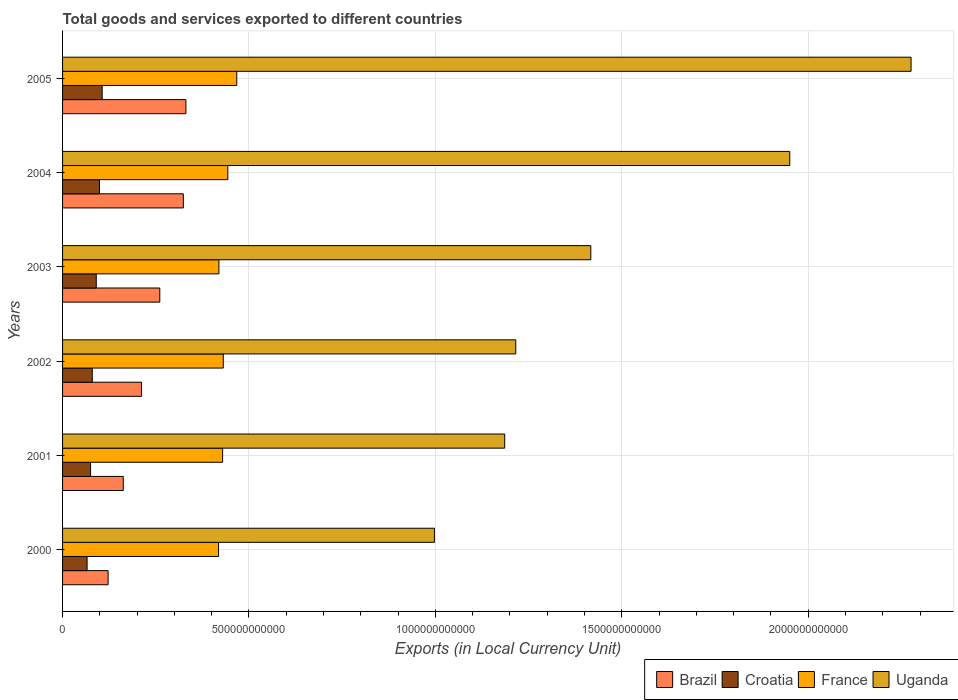How many different coloured bars are there?
Make the answer very short. 4. Are the number of bars per tick equal to the number of legend labels?
Keep it short and to the point. Yes. Are the number of bars on each tick of the Y-axis equal?
Keep it short and to the point. Yes. How many bars are there on the 3rd tick from the bottom?
Keep it short and to the point. 4. In how many cases, is the number of bars for a given year not equal to the number of legend labels?
Provide a short and direct response. 0. What is the Amount of goods and services exports in France in 2000?
Offer a terse response. 4.18e+11. Across all years, what is the maximum Amount of goods and services exports in Uganda?
Ensure brevity in your answer.  2.28e+12. Across all years, what is the minimum Amount of goods and services exports in Croatia?
Give a very brief answer. 6.58e+1. What is the total Amount of goods and services exports in France in the graph?
Provide a short and direct response. 2.61e+12. What is the difference between the Amount of goods and services exports in Croatia in 2003 and that in 2005?
Your answer should be compact. -1.58e+1. What is the difference between the Amount of goods and services exports in France in 2004 and the Amount of goods and services exports in Brazil in 2002?
Provide a succinct answer. 2.31e+11. What is the average Amount of goods and services exports in Uganda per year?
Ensure brevity in your answer.  1.51e+12. In the year 2002, what is the difference between the Amount of goods and services exports in France and Amount of goods and services exports in Uganda?
Make the answer very short. -7.85e+11. In how many years, is the Amount of goods and services exports in France greater than 900000000000 LCU?
Provide a short and direct response. 0. What is the ratio of the Amount of goods and services exports in Croatia in 2002 to that in 2003?
Provide a short and direct response. 0.88. Is the difference between the Amount of goods and services exports in France in 2001 and 2003 greater than the difference between the Amount of goods and services exports in Uganda in 2001 and 2003?
Your response must be concise. Yes. What is the difference between the highest and the second highest Amount of goods and services exports in Uganda?
Your answer should be compact. 3.25e+11. What is the difference between the highest and the lowest Amount of goods and services exports in Brazil?
Your answer should be compact. 2.09e+11. Is the sum of the Amount of goods and services exports in Croatia in 2002 and 2003 greater than the maximum Amount of goods and services exports in Uganda across all years?
Offer a very short reply. No. What does the 4th bar from the bottom in 2002 represents?
Provide a succinct answer. Uganda. Is it the case that in every year, the sum of the Amount of goods and services exports in Croatia and Amount of goods and services exports in France is greater than the Amount of goods and services exports in Brazil?
Provide a succinct answer. Yes. How many bars are there?
Make the answer very short. 24. What is the difference between two consecutive major ticks on the X-axis?
Provide a succinct answer. 5.00e+11. How are the legend labels stacked?
Offer a very short reply. Horizontal. What is the title of the graph?
Make the answer very short. Total goods and services exported to different countries. Does "Malawi" appear as one of the legend labels in the graph?
Your response must be concise. No. What is the label or title of the X-axis?
Make the answer very short. Exports (in Local Currency Unit). What is the Exports (in Local Currency Unit) in Brazil in 2000?
Provide a succinct answer. 1.22e+11. What is the Exports (in Local Currency Unit) in Croatia in 2000?
Give a very brief answer. 6.58e+1. What is the Exports (in Local Currency Unit) of France in 2000?
Offer a very short reply. 4.18e+11. What is the Exports (in Local Currency Unit) in Uganda in 2000?
Your response must be concise. 9.97e+11. What is the Exports (in Local Currency Unit) of Brazil in 2001?
Offer a very short reply. 1.63e+11. What is the Exports (in Local Currency Unit) in Croatia in 2001?
Ensure brevity in your answer.  7.51e+1. What is the Exports (in Local Currency Unit) of France in 2001?
Make the answer very short. 4.29e+11. What is the Exports (in Local Currency Unit) in Uganda in 2001?
Give a very brief answer. 1.19e+12. What is the Exports (in Local Currency Unit) in Brazil in 2002?
Make the answer very short. 2.12e+11. What is the Exports (in Local Currency Unit) of Croatia in 2002?
Make the answer very short. 7.97e+1. What is the Exports (in Local Currency Unit) in France in 2002?
Your response must be concise. 4.31e+11. What is the Exports (in Local Currency Unit) in Uganda in 2002?
Ensure brevity in your answer.  1.22e+12. What is the Exports (in Local Currency Unit) of Brazil in 2003?
Ensure brevity in your answer.  2.61e+11. What is the Exports (in Local Currency Unit) in Croatia in 2003?
Give a very brief answer. 9.04e+1. What is the Exports (in Local Currency Unit) in France in 2003?
Offer a very short reply. 4.19e+11. What is the Exports (in Local Currency Unit) of Uganda in 2003?
Provide a short and direct response. 1.42e+12. What is the Exports (in Local Currency Unit) in Brazil in 2004?
Offer a very short reply. 3.24e+11. What is the Exports (in Local Currency Unit) in Croatia in 2004?
Ensure brevity in your answer.  9.90e+1. What is the Exports (in Local Currency Unit) in France in 2004?
Provide a short and direct response. 4.43e+11. What is the Exports (in Local Currency Unit) in Uganda in 2004?
Your answer should be compact. 1.95e+12. What is the Exports (in Local Currency Unit) in Brazil in 2005?
Offer a very short reply. 3.31e+11. What is the Exports (in Local Currency Unit) in Croatia in 2005?
Provide a succinct answer. 1.06e+11. What is the Exports (in Local Currency Unit) in France in 2005?
Make the answer very short. 4.67e+11. What is the Exports (in Local Currency Unit) of Uganda in 2005?
Provide a succinct answer. 2.28e+12. Across all years, what is the maximum Exports (in Local Currency Unit) in Brazil?
Offer a very short reply. 3.31e+11. Across all years, what is the maximum Exports (in Local Currency Unit) of Croatia?
Your answer should be compact. 1.06e+11. Across all years, what is the maximum Exports (in Local Currency Unit) in France?
Your response must be concise. 4.67e+11. Across all years, what is the maximum Exports (in Local Currency Unit) in Uganda?
Provide a succinct answer. 2.28e+12. Across all years, what is the minimum Exports (in Local Currency Unit) of Brazil?
Offer a very short reply. 1.22e+11. Across all years, what is the minimum Exports (in Local Currency Unit) of Croatia?
Your response must be concise. 6.58e+1. Across all years, what is the minimum Exports (in Local Currency Unit) of France?
Provide a succinct answer. 4.18e+11. Across all years, what is the minimum Exports (in Local Currency Unit) of Uganda?
Your answer should be compact. 9.97e+11. What is the total Exports (in Local Currency Unit) in Brazil in the graph?
Make the answer very short. 1.41e+12. What is the total Exports (in Local Currency Unit) in Croatia in the graph?
Give a very brief answer. 5.16e+11. What is the total Exports (in Local Currency Unit) in France in the graph?
Your answer should be very brief. 2.61e+12. What is the total Exports (in Local Currency Unit) of Uganda in the graph?
Provide a short and direct response. 9.04e+12. What is the difference between the Exports (in Local Currency Unit) in Brazil in 2000 and that in 2001?
Make the answer very short. -4.06e+1. What is the difference between the Exports (in Local Currency Unit) in Croatia in 2000 and that in 2001?
Your answer should be very brief. -9.31e+09. What is the difference between the Exports (in Local Currency Unit) of France in 2000 and that in 2001?
Give a very brief answer. -1.09e+1. What is the difference between the Exports (in Local Currency Unit) in Uganda in 2000 and that in 2001?
Your answer should be compact. -1.89e+11. What is the difference between the Exports (in Local Currency Unit) of Brazil in 2000 and that in 2002?
Keep it short and to the point. -8.97e+1. What is the difference between the Exports (in Local Currency Unit) in Croatia in 2000 and that in 2002?
Keep it short and to the point. -1.39e+1. What is the difference between the Exports (in Local Currency Unit) in France in 2000 and that in 2002?
Your answer should be very brief. -1.26e+1. What is the difference between the Exports (in Local Currency Unit) in Uganda in 2000 and that in 2002?
Your answer should be very brief. -2.18e+11. What is the difference between the Exports (in Local Currency Unit) of Brazil in 2000 and that in 2003?
Offer a terse response. -1.39e+11. What is the difference between the Exports (in Local Currency Unit) of Croatia in 2000 and that in 2003?
Provide a succinct answer. -2.46e+1. What is the difference between the Exports (in Local Currency Unit) in France in 2000 and that in 2003?
Offer a very short reply. -9.01e+08. What is the difference between the Exports (in Local Currency Unit) in Uganda in 2000 and that in 2003?
Provide a short and direct response. -4.19e+11. What is the difference between the Exports (in Local Currency Unit) in Brazil in 2000 and that in 2004?
Provide a succinct answer. -2.02e+11. What is the difference between the Exports (in Local Currency Unit) of Croatia in 2000 and that in 2004?
Offer a very short reply. -3.32e+1. What is the difference between the Exports (in Local Currency Unit) in France in 2000 and that in 2004?
Offer a very short reply. -2.48e+1. What is the difference between the Exports (in Local Currency Unit) of Uganda in 2000 and that in 2004?
Give a very brief answer. -9.53e+11. What is the difference between the Exports (in Local Currency Unit) of Brazil in 2000 and that in 2005?
Ensure brevity in your answer.  -2.09e+11. What is the difference between the Exports (in Local Currency Unit) of Croatia in 2000 and that in 2005?
Keep it short and to the point. -4.04e+1. What is the difference between the Exports (in Local Currency Unit) in France in 2000 and that in 2005?
Provide a short and direct response. -4.88e+1. What is the difference between the Exports (in Local Currency Unit) in Uganda in 2000 and that in 2005?
Keep it short and to the point. -1.28e+12. What is the difference between the Exports (in Local Currency Unit) of Brazil in 2001 and that in 2002?
Provide a succinct answer. -4.91e+1. What is the difference between the Exports (in Local Currency Unit) in Croatia in 2001 and that in 2002?
Your answer should be very brief. -4.60e+09. What is the difference between the Exports (in Local Currency Unit) of France in 2001 and that in 2002?
Provide a short and direct response. -1.77e+09. What is the difference between the Exports (in Local Currency Unit) of Uganda in 2001 and that in 2002?
Keep it short and to the point. -2.97e+1. What is the difference between the Exports (in Local Currency Unit) in Brazil in 2001 and that in 2003?
Provide a succinct answer. -9.80e+1. What is the difference between the Exports (in Local Currency Unit) of Croatia in 2001 and that in 2003?
Offer a terse response. -1.53e+1. What is the difference between the Exports (in Local Currency Unit) of France in 2001 and that in 2003?
Make the answer very short. 9.96e+09. What is the difference between the Exports (in Local Currency Unit) of Uganda in 2001 and that in 2003?
Give a very brief answer. -2.31e+11. What is the difference between the Exports (in Local Currency Unit) in Brazil in 2001 and that in 2004?
Make the answer very short. -1.61e+11. What is the difference between the Exports (in Local Currency Unit) in Croatia in 2001 and that in 2004?
Your response must be concise. -2.39e+1. What is the difference between the Exports (in Local Currency Unit) of France in 2001 and that in 2004?
Make the answer very short. -1.39e+1. What is the difference between the Exports (in Local Currency Unit) of Uganda in 2001 and that in 2004?
Your answer should be very brief. -7.65e+11. What is the difference between the Exports (in Local Currency Unit) of Brazil in 2001 and that in 2005?
Your answer should be very brief. -1.68e+11. What is the difference between the Exports (in Local Currency Unit) in Croatia in 2001 and that in 2005?
Make the answer very short. -3.11e+1. What is the difference between the Exports (in Local Currency Unit) in France in 2001 and that in 2005?
Ensure brevity in your answer.  -3.79e+1. What is the difference between the Exports (in Local Currency Unit) in Uganda in 2001 and that in 2005?
Your answer should be compact. -1.09e+12. What is the difference between the Exports (in Local Currency Unit) in Brazil in 2002 and that in 2003?
Offer a terse response. -4.89e+1. What is the difference between the Exports (in Local Currency Unit) of Croatia in 2002 and that in 2003?
Offer a terse response. -1.07e+1. What is the difference between the Exports (in Local Currency Unit) in France in 2002 and that in 2003?
Your response must be concise. 1.17e+1. What is the difference between the Exports (in Local Currency Unit) in Uganda in 2002 and that in 2003?
Ensure brevity in your answer.  -2.01e+11. What is the difference between the Exports (in Local Currency Unit) in Brazil in 2002 and that in 2004?
Make the answer very short. -1.12e+11. What is the difference between the Exports (in Local Currency Unit) of Croatia in 2002 and that in 2004?
Your answer should be compact. -1.93e+1. What is the difference between the Exports (in Local Currency Unit) of France in 2002 and that in 2004?
Give a very brief answer. -1.22e+1. What is the difference between the Exports (in Local Currency Unit) of Uganda in 2002 and that in 2004?
Offer a very short reply. -7.35e+11. What is the difference between the Exports (in Local Currency Unit) in Brazil in 2002 and that in 2005?
Give a very brief answer. -1.19e+11. What is the difference between the Exports (in Local Currency Unit) of Croatia in 2002 and that in 2005?
Give a very brief answer. -2.65e+1. What is the difference between the Exports (in Local Currency Unit) of France in 2002 and that in 2005?
Keep it short and to the point. -3.62e+1. What is the difference between the Exports (in Local Currency Unit) of Uganda in 2002 and that in 2005?
Provide a short and direct response. -1.06e+12. What is the difference between the Exports (in Local Currency Unit) in Brazil in 2003 and that in 2004?
Ensure brevity in your answer.  -6.31e+1. What is the difference between the Exports (in Local Currency Unit) in Croatia in 2003 and that in 2004?
Provide a short and direct response. -8.61e+09. What is the difference between the Exports (in Local Currency Unit) in France in 2003 and that in 2004?
Make the answer very short. -2.39e+1. What is the difference between the Exports (in Local Currency Unit) of Uganda in 2003 and that in 2004?
Your answer should be compact. -5.34e+11. What is the difference between the Exports (in Local Currency Unit) in Brazil in 2003 and that in 2005?
Your answer should be very brief. -7.01e+1. What is the difference between the Exports (in Local Currency Unit) in Croatia in 2003 and that in 2005?
Make the answer very short. -1.58e+1. What is the difference between the Exports (in Local Currency Unit) in France in 2003 and that in 2005?
Give a very brief answer. -4.79e+1. What is the difference between the Exports (in Local Currency Unit) in Uganda in 2003 and that in 2005?
Ensure brevity in your answer.  -8.59e+11. What is the difference between the Exports (in Local Currency Unit) of Brazil in 2004 and that in 2005?
Ensure brevity in your answer.  -6.95e+09. What is the difference between the Exports (in Local Currency Unit) in Croatia in 2004 and that in 2005?
Offer a very short reply. -7.19e+09. What is the difference between the Exports (in Local Currency Unit) in France in 2004 and that in 2005?
Make the answer very short. -2.40e+1. What is the difference between the Exports (in Local Currency Unit) in Uganda in 2004 and that in 2005?
Provide a short and direct response. -3.25e+11. What is the difference between the Exports (in Local Currency Unit) in Brazil in 2000 and the Exports (in Local Currency Unit) in Croatia in 2001?
Offer a terse response. 4.71e+1. What is the difference between the Exports (in Local Currency Unit) in Brazil in 2000 and the Exports (in Local Currency Unit) in France in 2001?
Your answer should be very brief. -3.07e+11. What is the difference between the Exports (in Local Currency Unit) of Brazil in 2000 and the Exports (in Local Currency Unit) of Uganda in 2001?
Ensure brevity in your answer.  -1.06e+12. What is the difference between the Exports (in Local Currency Unit) in Croatia in 2000 and the Exports (in Local Currency Unit) in France in 2001?
Provide a succinct answer. -3.64e+11. What is the difference between the Exports (in Local Currency Unit) in Croatia in 2000 and the Exports (in Local Currency Unit) in Uganda in 2001?
Ensure brevity in your answer.  -1.12e+12. What is the difference between the Exports (in Local Currency Unit) of France in 2000 and the Exports (in Local Currency Unit) of Uganda in 2001?
Your response must be concise. -7.67e+11. What is the difference between the Exports (in Local Currency Unit) in Brazil in 2000 and the Exports (in Local Currency Unit) in Croatia in 2002?
Your answer should be very brief. 4.25e+1. What is the difference between the Exports (in Local Currency Unit) of Brazil in 2000 and the Exports (in Local Currency Unit) of France in 2002?
Your response must be concise. -3.09e+11. What is the difference between the Exports (in Local Currency Unit) of Brazil in 2000 and the Exports (in Local Currency Unit) of Uganda in 2002?
Give a very brief answer. -1.09e+12. What is the difference between the Exports (in Local Currency Unit) of Croatia in 2000 and the Exports (in Local Currency Unit) of France in 2002?
Provide a short and direct response. -3.65e+11. What is the difference between the Exports (in Local Currency Unit) of Croatia in 2000 and the Exports (in Local Currency Unit) of Uganda in 2002?
Your answer should be very brief. -1.15e+12. What is the difference between the Exports (in Local Currency Unit) in France in 2000 and the Exports (in Local Currency Unit) in Uganda in 2002?
Provide a short and direct response. -7.97e+11. What is the difference between the Exports (in Local Currency Unit) in Brazil in 2000 and the Exports (in Local Currency Unit) in Croatia in 2003?
Provide a succinct answer. 3.18e+1. What is the difference between the Exports (in Local Currency Unit) of Brazil in 2000 and the Exports (in Local Currency Unit) of France in 2003?
Your answer should be compact. -2.97e+11. What is the difference between the Exports (in Local Currency Unit) in Brazil in 2000 and the Exports (in Local Currency Unit) in Uganda in 2003?
Ensure brevity in your answer.  -1.29e+12. What is the difference between the Exports (in Local Currency Unit) in Croatia in 2000 and the Exports (in Local Currency Unit) in France in 2003?
Provide a succinct answer. -3.54e+11. What is the difference between the Exports (in Local Currency Unit) of Croatia in 2000 and the Exports (in Local Currency Unit) of Uganda in 2003?
Keep it short and to the point. -1.35e+12. What is the difference between the Exports (in Local Currency Unit) of France in 2000 and the Exports (in Local Currency Unit) of Uganda in 2003?
Ensure brevity in your answer.  -9.98e+11. What is the difference between the Exports (in Local Currency Unit) of Brazil in 2000 and the Exports (in Local Currency Unit) of Croatia in 2004?
Your answer should be compact. 2.32e+1. What is the difference between the Exports (in Local Currency Unit) in Brazil in 2000 and the Exports (in Local Currency Unit) in France in 2004?
Ensure brevity in your answer.  -3.21e+11. What is the difference between the Exports (in Local Currency Unit) in Brazil in 2000 and the Exports (in Local Currency Unit) in Uganda in 2004?
Give a very brief answer. -1.83e+12. What is the difference between the Exports (in Local Currency Unit) in Croatia in 2000 and the Exports (in Local Currency Unit) in France in 2004?
Give a very brief answer. -3.77e+11. What is the difference between the Exports (in Local Currency Unit) in Croatia in 2000 and the Exports (in Local Currency Unit) in Uganda in 2004?
Your answer should be very brief. -1.88e+12. What is the difference between the Exports (in Local Currency Unit) of France in 2000 and the Exports (in Local Currency Unit) of Uganda in 2004?
Make the answer very short. -1.53e+12. What is the difference between the Exports (in Local Currency Unit) in Brazil in 2000 and the Exports (in Local Currency Unit) in Croatia in 2005?
Keep it short and to the point. 1.60e+1. What is the difference between the Exports (in Local Currency Unit) of Brazil in 2000 and the Exports (in Local Currency Unit) of France in 2005?
Give a very brief answer. -3.45e+11. What is the difference between the Exports (in Local Currency Unit) of Brazil in 2000 and the Exports (in Local Currency Unit) of Uganda in 2005?
Your answer should be very brief. -2.15e+12. What is the difference between the Exports (in Local Currency Unit) of Croatia in 2000 and the Exports (in Local Currency Unit) of France in 2005?
Provide a short and direct response. -4.01e+11. What is the difference between the Exports (in Local Currency Unit) in Croatia in 2000 and the Exports (in Local Currency Unit) in Uganda in 2005?
Make the answer very short. -2.21e+12. What is the difference between the Exports (in Local Currency Unit) in France in 2000 and the Exports (in Local Currency Unit) in Uganda in 2005?
Keep it short and to the point. -1.86e+12. What is the difference between the Exports (in Local Currency Unit) in Brazil in 2001 and the Exports (in Local Currency Unit) in Croatia in 2002?
Your response must be concise. 8.31e+1. What is the difference between the Exports (in Local Currency Unit) in Brazil in 2001 and the Exports (in Local Currency Unit) in France in 2002?
Offer a terse response. -2.68e+11. What is the difference between the Exports (in Local Currency Unit) of Brazil in 2001 and the Exports (in Local Currency Unit) of Uganda in 2002?
Provide a short and direct response. -1.05e+12. What is the difference between the Exports (in Local Currency Unit) of Croatia in 2001 and the Exports (in Local Currency Unit) of France in 2002?
Offer a very short reply. -3.56e+11. What is the difference between the Exports (in Local Currency Unit) of Croatia in 2001 and the Exports (in Local Currency Unit) of Uganda in 2002?
Provide a succinct answer. -1.14e+12. What is the difference between the Exports (in Local Currency Unit) of France in 2001 and the Exports (in Local Currency Unit) of Uganda in 2002?
Provide a short and direct response. -7.86e+11. What is the difference between the Exports (in Local Currency Unit) of Brazil in 2001 and the Exports (in Local Currency Unit) of Croatia in 2003?
Give a very brief answer. 7.24e+1. What is the difference between the Exports (in Local Currency Unit) of Brazil in 2001 and the Exports (in Local Currency Unit) of France in 2003?
Offer a terse response. -2.57e+11. What is the difference between the Exports (in Local Currency Unit) of Brazil in 2001 and the Exports (in Local Currency Unit) of Uganda in 2003?
Make the answer very short. -1.25e+12. What is the difference between the Exports (in Local Currency Unit) of Croatia in 2001 and the Exports (in Local Currency Unit) of France in 2003?
Provide a succinct answer. -3.44e+11. What is the difference between the Exports (in Local Currency Unit) of Croatia in 2001 and the Exports (in Local Currency Unit) of Uganda in 2003?
Offer a very short reply. -1.34e+12. What is the difference between the Exports (in Local Currency Unit) in France in 2001 and the Exports (in Local Currency Unit) in Uganda in 2003?
Make the answer very short. -9.88e+11. What is the difference between the Exports (in Local Currency Unit) in Brazil in 2001 and the Exports (in Local Currency Unit) in Croatia in 2004?
Provide a short and direct response. 6.38e+1. What is the difference between the Exports (in Local Currency Unit) in Brazil in 2001 and the Exports (in Local Currency Unit) in France in 2004?
Give a very brief answer. -2.80e+11. What is the difference between the Exports (in Local Currency Unit) of Brazil in 2001 and the Exports (in Local Currency Unit) of Uganda in 2004?
Your answer should be compact. -1.79e+12. What is the difference between the Exports (in Local Currency Unit) of Croatia in 2001 and the Exports (in Local Currency Unit) of France in 2004?
Your answer should be compact. -3.68e+11. What is the difference between the Exports (in Local Currency Unit) of Croatia in 2001 and the Exports (in Local Currency Unit) of Uganda in 2004?
Offer a terse response. -1.88e+12. What is the difference between the Exports (in Local Currency Unit) in France in 2001 and the Exports (in Local Currency Unit) in Uganda in 2004?
Give a very brief answer. -1.52e+12. What is the difference between the Exports (in Local Currency Unit) in Brazil in 2001 and the Exports (in Local Currency Unit) in Croatia in 2005?
Provide a succinct answer. 5.66e+1. What is the difference between the Exports (in Local Currency Unit) in Brazil in 2001 and the Exports (in Local Currency Unit) in France in 2005?
Offer a terse response. -3.04e+11. What is the difference between the Exports (in Local Currency Unit) of Brazil in 2001 and the Exports (in Local Currency Unit) of Uganda in 2005?
Offer a very short reply. -2.11e+12. What is the difference between the Exports (in Local Currency Unit) in Croatia in 2001 and the Exports (in Local Currency Unit) in France in 2005?
Provide a succinct answer. -3.92e+11. What is the difference between the Exports (in Local Currency Unit) in Croatia in 2001 and the Exports (in Local Currency Unit) in Uganda in 2005?
Ensure brevity in your answer.  -2.20e+12. What is the difference between the Exports (in Local Currency Unit) in France in 2001 and the Exports (in Local Currency Unit) in Uganda in 2005?
Make the answer very short. -1.85e+12. What is the difference between the Exports (in Local Currency Unit) in Brazil in 2002 and the Exports (in Local Currency Unit) in Croatia in 2003?
Your answer should be very brief. 1.21e+11. What is the difference between the Exports (in Local Currency Unit) in Brazil in 2002 and the Exports (in Local Currency Unit) in France in 2003?
Make the answer very short. -2.07e+11. What is the difference between the Exports (in Local Currency Unit) of Brazil in 2002 and the Exports (in Local Currency Unit) of Uganda in 2003?
Your answer should be compact. -1.21e+12. What is the difference between the Exports (in Local Currency Unit) of Croatia in 2002 and the Exports (in Local Currency Unit) of France in 2003?
Your answer should be compact. -3.40e+11. What is the difference between the Exports (in Local Currency Unit) of Croatia in 2002 and the Exports (in Local Currency Unit) of Uganda in 2003?
Provide a short and direct response. -1.34e+12. What is the difference between the Exports (in Local Currency Unit) of France in 2002 and the Exports (in Local Currency Unit) of Uganda in 2003?
Offer a very short reply. -9.86e+11. What is the difference between the Exports (in Local Currency Unit) of Brazil in 2002 and the Exports (in Local Currency Unit) of Croatia in 2004?
Keep it short and to the point. 1.13e+11. What is the difference between the Exports (in Local Currency Unit) in Brazil in 2002 and the Exports (in Local Currency Unit) in France in 2004?
Your answer should be very brief. -2.31e+11. What is the difference between the Exports (in Local Currency Unit) in Brazil in 2002 and the Exports (in Local Currency Unit) in Uganda in 2004?
Provide a succinct answer. -1.74e+12. What is the difference between the Exports (in Local Currency Unit) in Croatia in 2002 and the Exports (in Local Currency Unit) in France in 2004?
Keep it short and to the point. -3.64e+11. What is the difference between the Exports (in Local Currency Unit) of Croatia in 2002 and the Exports (in Local Currency Unit) of Uganda in 2004?
Your answer should be very brief. -1.87e+12. What is the difference between the Exports (in Local Currency Unit) of France in 2002 and the Exports (in Local Currency Unit) of Uganda in 2004?
Your response must be concise. -1.52e+12. What is the difference between the Exports (in Local Currency Unit) in Brazil in 2002 and the Exports (in Local Currency Unit) in Croatia in 2005?
Your answer should be very brief. 1.06e+11. What is the difference between the Exports (in Local Currency Unit) of Brazil in 2002 and the Exports (in Local Currency Unit) of France in 2005?
Provide a short and direct response. -2.55e+11. What is the difference between the Exports (in Local Currency Unit) in Brazil in 2002 and the Exports (in Local Currency Unit) in Uganda in 2005?
Ensure brevity in your answer.  -2.06e+12. What is the difference between the Exports (in Local Currency Unit) of Croatia in 2002 and the Exports (in Local Currency Unit) of France in 2005?
Your answer should be very brief. -3.88e+11. What is the difference between the Exports (in Local Currency Unit) in Croatia in 2002 and the Exports (in Local Currency Unit) in Uganda in 2005?
Provide a succinct answer. -2.20e+12. What is the difference between the Exports (in Local Currency Unit) of France in 2002 and the Exports (in Local Currency Unit) of Uganda in 2005?
Provide a succinct answer. -1.84e+12. What is the difference between the Exports (in Local Currency Unit) of Brazil in 2003 and the Exports (in Local Currency Unit) of Croatia in 2004?
Provide a short and direct response. 1.62e+11. What is the difference between the Exports (in Local Currency Unit) of Brazil in 2003 and the Exports (in Local Currency Unit) of France in 2004?
Offer a terse response. -1.82e+11. What is the difference between the Exports (in Local Currency Unit) in Brazil in 2003 and the Exports (in Local Currency Unit) in Uganda in 2004?
Offer a terse response. -1.69e+12. What is the difference between the Exports (in Local Currency Unit) of Croatia in 2003 and the Exports (in Local Currency Unit) of France in 2004?
Provide a short and direct response. -3.53e+11. What is the difference between the Exports (in Local Currency Unit) of Croatia in 2003 and the Exports (in Local Currency Unit) of Uganda in 2004?
Provide a short and direct response. -1.86e+12. What is the difference between the Exports (in Local Currency Unit) of France in 2003 and the Exports (in Local Currency Unit) of Uganda in 2004?
Your answer should be very brief. -1.53e+12. What is the difference between the Exports (in Local Currency Unit) of Brazil in 2003 and the Exports (in Local Currency Unit) of Croatia in 2005?
Give a very brief answer. 1.55e+11. What is the difference between the Exports (in Local Currency Unit) of Brazil in 2003 and the Exports (in Local Currency Unit) of France in 2005?
Offer a terse response. -2.06e+11. What is the difference between the Exports (in Local Currency Unit) in Brazil in 2003 and the Exports (in Local Currency Unit) in Uganda in 2005?
Offer a very short reply. -2.02e+12. What is the difference between the Exports (in Local Currency Unit) of Croatia in 2003 and the Exports (in Local Currency Unit) of France in 2005?
Ensure brevity in your answer.  -3.77e+11. What is the difference between the Exports (in Local Currency Unit) in Croatia in 2003 and the Exports (in Local Currency Unit) in Uganda in 2005?
Your response must be concise. -2.19e+12. What is the difference between the Exports (in Local Currency Unit) in France in 2003 and the Exports (in Local Currency Unit) in Uganda in 2005?
Offer a terse response. -1.86e+12. What is the difference between the Exports (in Local Currency Unit) in Brazil in 2004 and the Exports (in Local Currency Unit) in Croatia in 2005?
Keep it short and to the point. 2.18e+11. What is the difference between the Exports (in Local Currency Unit) of Brazil in 2004 and the Exports (in Local Currency Unit) of France in 2005?
Offer a very short reply. -1.43e+11. What is the difference between the Exports (in Local Currency Unit) in Brazil in 2004 and the Exports (in Local Currency Unit) in Uganda in 2005?
Give a very brief answer. -1.95e+12. What is the difference between the Exports (in Local Currency Unit) in Croatia in 2004 and the Exports (in Local Currency Unit) in France in 2005?
Provide a short and direct response. -3.68e+11. What is the difference between the Exports (in Local Currency Unit) of Croatia in 2004 and the Exports (in Local Currency Unit) of Uganda in 2005?
Make the answer very short. -2.18e+12. What is the difference between the Exports (in Local Currency Unit) of France in 2004 and the Exports (in Local Currency Unit) of Uganda in 2005?
Offer a very short reply. -1.83e+12. What is the average Exports (in Local Currency Unit) in Brazil per year?
Your answer should be compact. 2.35e+11. What is the average Exports (in Local Currency Unit) of Croatia per year?
Give a very brief answer. 8.60e+1. What is the average Exports (in Local Currency Unit) of France per year?
Provide a short and direct response. 4.35e+11. What is the average Exports (in Local Currency Unit) in Uganda per year?
Keep it short and to the point. 1.51e+12. In the year 2000, what is the difference between the Exports (in Local Currency Unit) of Brazil and Exports (in Local Currency Unit) of Croatia?
Your answer should be compact. 5.64e+1. In the year 2000, what is the difference between the Exports (in Local Currency Unit) of Brazil and Exports (in Local Currency Unit) of France?
Provide a succinct answer. -2.96e+11. In the year 2000, what is the difference between the Exports (in Local Currency Unit) in Brazil and Exports (in Local Currency Unit) in Uganda?
Your response must be concise. -8.75e+11. In the year 2000, what is the difference between the Exports (in Local Currency Unit) of Croatia and Exports (in Local Currency Unit) of France?
Your answer should be compact. -3.53e+11. In the year 2000, what is the difference between the Exports (in Local Currency Unit) of Croatia and Exports (in Local Currency Unit) of Uganda?
Ensure brevity in your answer.  -9.32e+11. In the year 2000, what is the difference between the Exports (in Local Currency Unit) in France and Exports (in Local Currency Unit) in Uganda?
Ensure brevity in your answer.  -5.79e+11. In the year 2001, what is the difference between the Exports (in Local Currency Unit) of Brazil and Exports (in Local Currency Unit) of Croatia?
Your answer should be compact. 8.77e+1. In the year 2001, what is the difference between the Exports (in Local Currency Unit) of Brazil and Exports (in Local Currency Unit) of France?
Make the answer very short. -2.67e+11. In the year 2001, what is the difference between the Exports (in Local Currency Unit) of Brazil and Exports (in Local Currency Unit) of Uganda?
Make the answer very short. -1.02e+12. In the year 2001, what is the difference between the Exports (in Local Currency Unit) of Croatia and Exports (in Local Currency Unit) of France?
Provide a short and direct response. -3.54e+11. In the year 2001, what is the difference between the Exports (in Local Currency Unit) in Croatia and Exports (in Local Currency Unit) in Uganda?
Make the answer very short. -1.11e+12. In the year 2001, what is the difference between the Exports (in Local Currency Unit) in France and Exports (in Local Currency Unit) in Uganda?
Offer a very short reply. -7.57e+11. In the year 2002, what is the difference between the Exports (in Local Currency Unit) in Brazil and Exports (in Local Currency Unit) in Croatia?
Offer a terse response. 1.32e+11. In the year 2002, what is the difference between the Exports (in Local Currency Unit) in Brazil and Exports (in Local Currency Unit) in France?
Ensure brevity in your answer.  -2.19e+11. In the year 2002, what is the difference between the Exports (in Local Currency Unit) of Brazil and Exports (in Local Currency Unit) of Uganda?
Offer a terse response. -1.00e+12. In the year 2002, what is the difference between the Exports (in Local Currency Unit) in Croatia and Exports (in Local Currency Unit) in France?
Give a very brief answer. -3.51e+11. In the year 2002, what is the difference between the Exports (in Local Currency Unit) in Croatia and Exports (in Local Currency Unit) in Uganda?
Your response must be concise. -1.14e+12. In the year 2002, what is the difference between the Exports (in Local Currency Unit) of France and Exports (in Local Currency Unit) of Uganda?
Provide a short and direct response. -7.85e+11. In the year 2003, what is the difference between the Exports (in Local Currency Unit) of Brazil and Exports (in Local Currency Unit) of Croatia?
Your response must be concise. 1.70e+11. In the year 2003, what is the difference between the Exports (in Local Currency Unit) in Brazil and Exports (in Local Currency Unit) in France?
Ensure brevity in your answer.  -1.59e+11. In the year 2003, what is the difference between the Exports (in Local Currency Unit) in Brazil and Exports (in Local Currency Unit) in Uganda?
Provide a succinct answer. -1.16e+12. In the year 2003, what is the difference between the Exports (in Local Currency Unit) of Croatia and Exports (in Local Currency Unit) of France?
Your response must be concise. -3.29e+11. In the year 2003, what is the difference between the Exports (in Local Currency Unit) in Croatia and Exports (in Local Currency Unit) in Uganda?
Your response must be concise. -1.33e+12. In the year 2003, what is the difference between the Exports (in Local Currency Unit) in France and Exports (in Local Currency Unit) in Uganda?
Your answer should be compact. -9.98e+11. In the year 2004, what is the difference between the Exports (in Local Currency Unit) in Brazil and Exports (in Local Currency Unit) in Croatia?
Offer a very short reply. 2.25e+11. In the year 2004, what is the difference between the Exports (in Local Currency Unit) of Brazil and Exports (in Local Currency Unit) of France?
Your answer should be compact. -1.19e+11. In the year 2004, what is the difference between the Exports (in Local Currency Unit) of Brazil and Exports (in Local Currency Unit) of Uganda?
Offer a terse response. -1.63e+12. In the year 2004, what is the difference between the Exports (in Local Currency Unit) in Croatia and Exports (in Local Currency Unit) in France?
Your answer should be very brief. -3.44e+11. In the year 2004, what is the difference between the Exports (in Local Currency Unit) in Croatia and Exports (in Local Currency Unit) in Uganda?
Keep it short and to the point. -1.85e+12. In the year 2004, what is the difference between the Exports (in Local Currency Unit) in France and Exports (in Local Currency Unit) in Uganda?
Provide a succinct answer. -1.51e+12. In the year 2005, what is the difference between the Exports (in Local Currency Unit) in Brazil and Exports (in Local Currency Unit) in Croatia?
Give a very brief answer. 2.25e+11. In the year 2005, what is the difference between the Exports (in Local Currency Unit) in Brazil and Exports (in Local Currency Unit) in France?
Offer a terse response. -1.36e+11. In the year 2005, what is the difference between the Exports (in Local Currency Unit) of Brazil and Exports (in Local Currency Unit) of Uganda?
Your answer should be compact. -1.95e+12. In the year 2005, what is the difference between the Exports (in Local Currency Unit) in Croatia and Exports (in Local Currency Unit) in France?
Make the answer very short. -3.61e+11. In the year 2005, what is the difference between the Exports (in Local Currency Unit) in Croatia and Exports (in Local Currency Unit) in Uganda?
Your answer should be compact. -2.17e+12. In the year 2005, what is the difference between the Exports (in Local Currency Unit) in France and Exports (in Local Currency Unit) in Uganda?
Your response must be concise. -1.81e+12. What is the ratio of the Exports (in Local Currency Unit) of Brazil in 2000 to that in 2001?
Offer a terse response. 0.75. What is the ratio of the Exports (in Local Currency Unit) of Croatia in 2000 to that in 2001?
Provide a short and direct response. 0.88. What is the ratio of the Exports (in Local Currency Unit) of France in 2000 to that in 2001?
Keep it short and to the point. 0.97. What is the ratio of the Exports (in Local Currency Unit) in Uganda in 2000 to that in 2001?
Your response must be concise. 0.84. What is the ratio of the Exports (in Local Currency Unit) in Brazil in 2000 to that in 2002?
Give a very brief answer. 0.58. What is the ratio of the Exports (in Local Currency Unit) of Croatia in 2000 to that in 2002?
Ensure brevity in your answer.  0.83. What is the ratio of the Exports (in Local Currency Unit) in France in 2000 to that in 2002?
Your response must be concise. 0.97. What is the ratio of the Exports (in Local Currency Unit) of Uganda in 2000 to that in 2002?
Keep it short and to the point. 0.82. What is the ratio of the Exports (in Local Currency Unit) in Brazil in 2000 to that in 2003?
Ensure brevity in your answer.  0.47. What is the ratio of the Exports (in Local Currency Unit) of Croatia in 2000 to that in 2003?
Offer a terse response. 0.73. What is the ratio of the Exports (in Local Currency Unit) in Uganda in 2000 to that in 2003?
Offer a very short reply. 0.7. What is the ratio of the Exports (in Local Currency Unit) of Brazil in 2000 to that in 2004?
Make the answer very short. 0.38. What is the ratio of the Exports (in Local Currency Unit) of Croatia in 2000 to that in 2004?
Your answer should be compact. 0.66. What is the ratio of the Exports (in Local Currency Unit) of France in 2000 to that in 2004?
Give a very brief answer. 0.94. What is the ratio of the Exports (in Local Currency Unit) in Uganda in 2000 to that in 2004?
Make the answer very short. 0.51. What is the ratio of the Exports (in Local Currency Unit) of Brazil in 2000 to that in 2005?
Give a very brief answer. 0.37. What is the ratio of the Exports (in Local Currency Unit) of Croatia in 2000 to that in 2005?
Offer a terse response. 0.62. What is the ratio of the Exports (in Local Currency Unit) of France in 2000 to that in 2005?
Ensure brevity in your answer.  0.9. What is the ratio of the Exports (in Local Currency Unit) in Uganda in 2000 to that in 2005?
Provide a short and direct response. 0.44. What is the ratio of the Exports (in Local Currency Unit) in Brazil in 2001 to that in 2002?
Your response must be concise. 0.77. What is the ratio of the Exports (in Local Currency Unit) of Croatia in 2001 to that in 2002?
Ensure brevity in your answer.  0.94. What is the ratio of the Exports (in Local Currency Unit) in Uganda in 2001 to that in 2002?
Provide a succinct answer. 0.98. What is the ratio of the Exports (in Local Currency Unit) of Brazil in 2001 to that in 2003?
Provide a succinct answer. 0.62. What is the ratio of the Exports (in Local Currency Unit) in Croatia in 2001 to that in 2003?
Provide a short and direct response. 0.83. What is the ratio of the Exports (in Local Currency Unit) of France in 2001 to that in 2003?
Provide a succinct answer. 1.02. What is the ratio of the Exports (in Local Currency Unit) in Uganda in 2001 to that in 2003?
Provide a succinct answer. 0.84. What is the ratio of the Exports (in Local Currency Unit) of Brazil in 2001 to that in 2004?
Offer a terse response. 0.5. What is the ratio of the Exports (in Local Currency Unit) of Croatia in 2001 to that in 2004?
Your response must be concise. 0.76. What is the ratio of the Exports (in Local Currency Unit) of France in 2001 to that in 2004?
Your answer should be very brief. 0.97. What is the ratio of the Exports (in Local Currency Unit) in Uganda in 2001 to that in 2004?
Offer a very short reply. 0.61. What is the ratio of the Exports (in Local Currency Unit) of Brazil in 2001 to that in 2005?
Your response must be concise. 0.49. What is the ratio of the Exports (in Local Currency Unit) in Croatia in 2001 to that in 2005?
Keep it short and to the point. 0.71. What is the ratio of the Exports (in Local Currency Unit) in France in 2001 to that in 2005?
Give a very brief answer. 0.92. What is the ratio of the Exports (in Local Currency Unit) of Uganda in 2001 to that in 2005?
Offer a very short reply. 0.52. What is the ratio of the Exports (in Local Currency Unit) in Brazil in 2002 to that in 2003?
Your response must be concise. 0.81. What is the ratio of the Exports (in Local Currency Unit) in Croatia in 2002 to that in 2003?
Provide a succinct answer. 0.88. What is the ratio of the Exports (in Local Currency Unit) of France in 2002 to that in 2003?
Your answer should be very brief. 1.03. What is the ratio of the Exports (in Local Currency Unit) of Uganda in 2002 to that in 2003?
Keep it short and to the point. 0.86. What is the ratio of the Exports (in Local Currency Unit) of Brazil in 2002 to that in 2004?
Offer a terse response. 0.65. What is the ratio of the Exports (in Local Currency Unit) in Croatia in 2002 to that in 2004?
Offer a terse response. 0.81. What is the ratio of the Exports (in Local Currency Unit) of France in 2002 to that in 2004?
Provide a short and direct response. 0.97. What is the ratio of the Exports (in Local Currency Unit) in Uganda in 2002 to that in 2004?
Offer a very short reply. 0.62. What is the ratio of the Exports (in Local Currency Unit) of Brazil in 2002 to that in 2005?
Make the answer very short. 0.64. What is the ratio of the Exports (in Local Currency Unit) in Croatia in 2002 to that in 2005?
Your answer should be compact. 0.75. What is the ratio of the Exports (in Local Currency Unit) of France in 2002 to that in 2005?
Provide a succinct answer. 0.92. What is the ratio of the Exports (in Local Currency Unit) of Uganda in 2002 to that in 2005?
Make the answer very short. 0.53. What is the ratio of the Exports (in Local Currency Unit) in Brazil in 2003 to that in 2004?
Offer a terse response. 0.81. What is the ratio of the Exports (in Local Currency Unit) in France in 2003 to that in 2004?
Provide a short and direct response. 0.95. What is the ratio of the Exports (in Local Currency Unit) in Uganda in 2003 to that in 2004?
Keep it short and to the point. 0.73. What is the ratio of the Exports (in Local Currency Unit) in Brazil in 2003 to that in 2005?
Give a very brief answer. 0.79. What is the ratio of the Exports (in Local Currency Unit) in Croatia in 2003 to that in 2005?
Your answer should be compact. 0.85. What is the ratio of the Exports (in Local Currency Unit) of France in 2003 to that in 2005?
Your response must be concise. 0.9. What is the ratio of the Exports (in Local Currency Unit) of Uganda in 2003 to that in 2005?
Provide a short and direct response. 0.62. What is the ratio of the Exports (in Local Currency Unit) of Croatia in 2004 to that in 2005?
Offer a very short reply. 0.93. What is the ratio of the Exports (in Local Currency Unit) of France in 2004 to that in 2005?
Keep it short and to the point. 0.95. What is the ratio of the Exports (in Local Currency Unit) of Uganda in 2004 to that in 2005?
Keep it short and to the point. 0.86. What is the difference between the highest and the second highest Exports (in Local Currency Unit) of Brazil?
Make the answer very short. 6.95e+09. What is the difference between the highest and the second highest Exports (in Local Currency Unit) of Croatia?
Your answer should be compact. 7.19e+09. What is the difference between the highest and the second highest Exports (in Local Currency Unit) in France?
Keep it short and to the point. 2.40e+1. What is the difference between the highest and the second highest Exports (in Local Currency Unit) in Uganda?
Your answer should be compact. 3.25e+11. What is the difference between the highest and the lowest Exports (in Local Currency Unit) in Brazil?
Provide a succinct answer. 2.09e+11. What is the difference between the highest and the lowest Exports (in Local Currency Unit) in Croatia?
Your response must be concise. 4.04e+1. What is the difference between the highest and the lowest Exports (in Local Currency Unit) of France?
Offer a very short reply. 4.88e+1. What is the difference between the highest and the lowest Exports (in Local Currency Unit) in Uganda?
Give a very brief answer. 1.28e+12. 